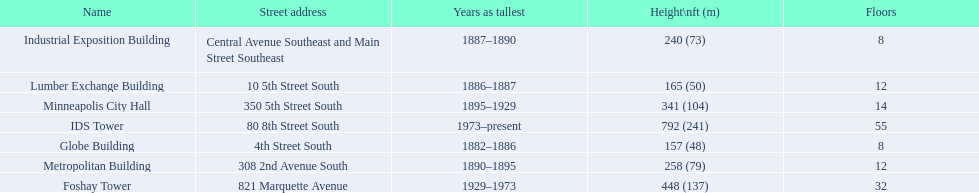How tall is it to the top of the ids tower in feet? 792. 